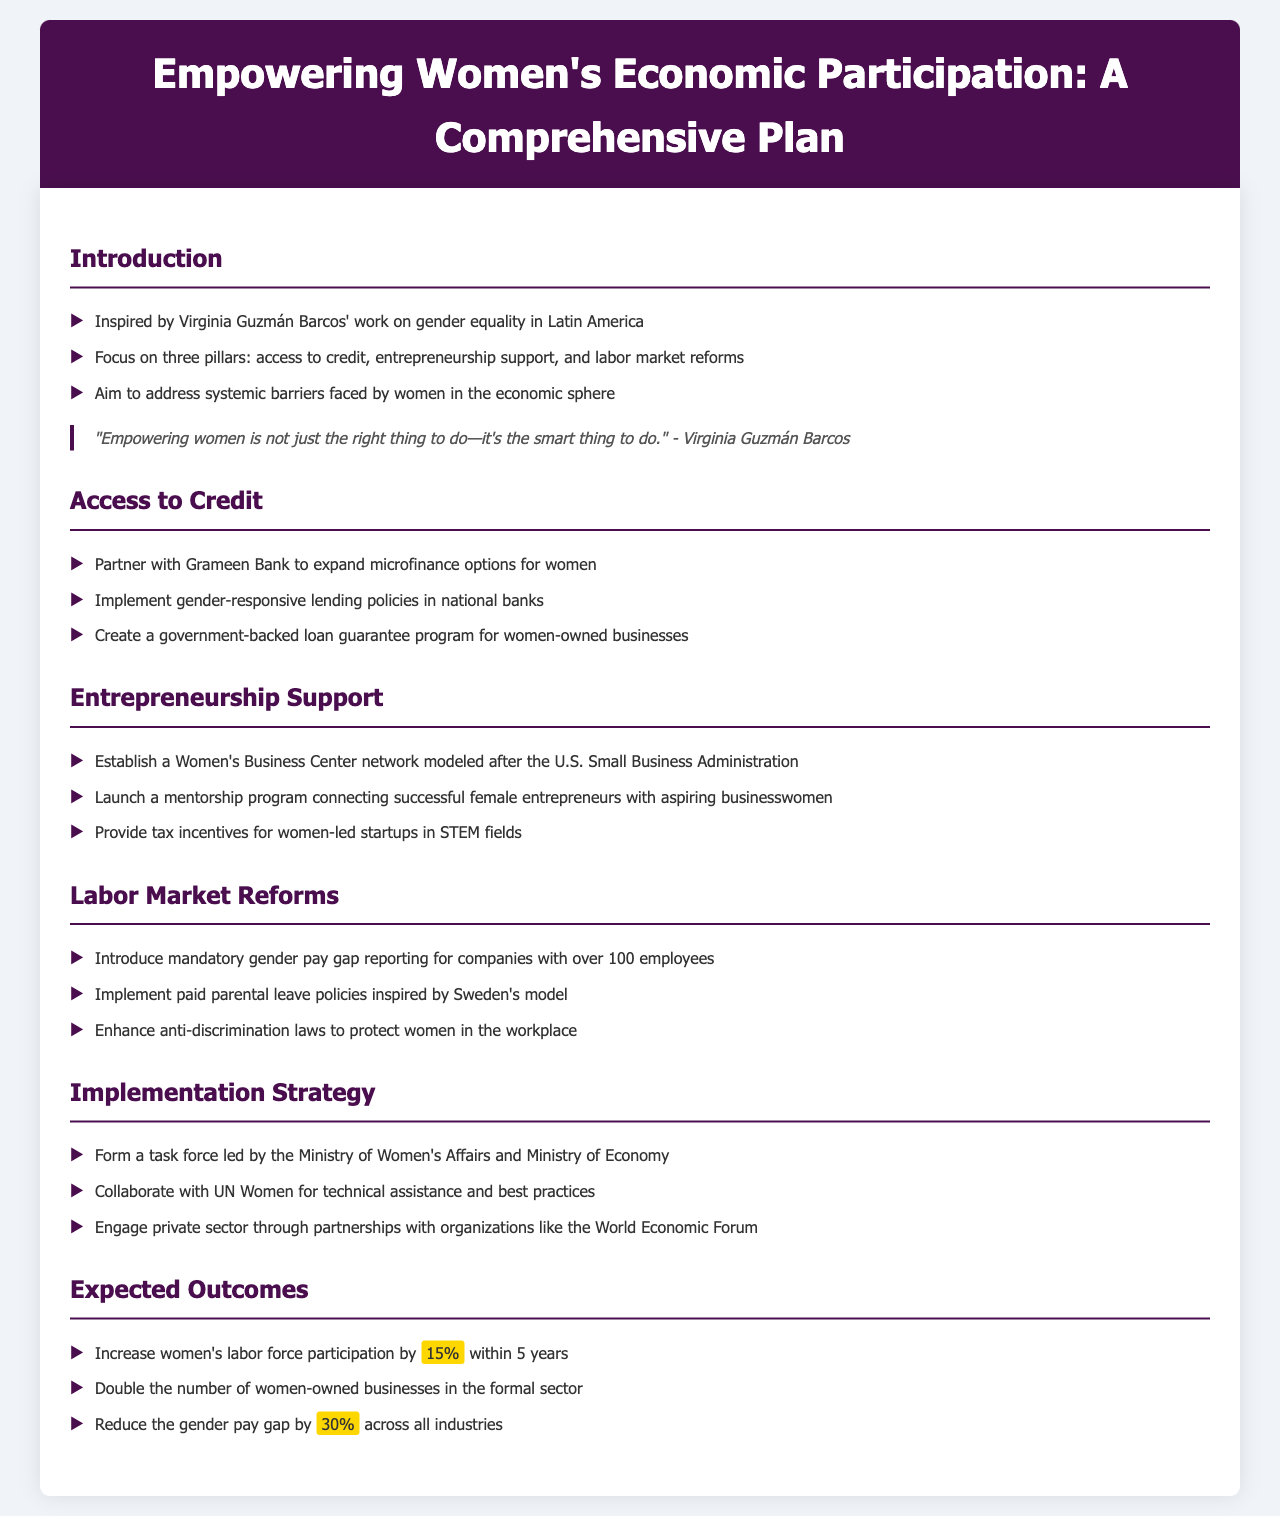What is the focus of the comprehensive plan? The document outlines a plan focused on access to credit, entrepreneurship support, and labor market reforms for women's economic empowerment.
Answer: access to credit, entrepreneurship support, and labor market reforms Who is the document inspired by? The introduction states that the plan is inspired by the work of Virginia Guzmán Barcos on gender equality in Latin America.
Answer: Virginia Guzmán Barcos What program is suggested for women-owned businesses? A government-backed loan guarantee program is proposed in the section on access to credit to support women-owned businesses.
Answer: government-backed loan guarantee program What is the expected increase in women's labor force participation? The document anticipates a 15% increase in women's labor force participation within five years.
Answer: 15% What kind of network is proposed to support women entrepreneurs? The proposal includes establishing a Women's Business Center network modeled after the U.S. Small Business Administration.
Answer: Women's Business Center network What reform is suggested for companies with over 100 employees? Mandatory gender pay gap reporting is suggested for companies exceeding 100 employees in the labor market reforms section.
Answer: mandatory gender pay gap reporting Which ministry will lead the task force? The task force will be led by the Ministry of Women's Affairs as stated in the implementation strategy section.
Answer: Ministry of Women's Affairs What is a tax incentive mentioned in relation to women's entrepreneurship? The plan includes providing tax incentives for women-led startups in STEM fields.
Answer: tax incentives for women-led startups in STEM fields 